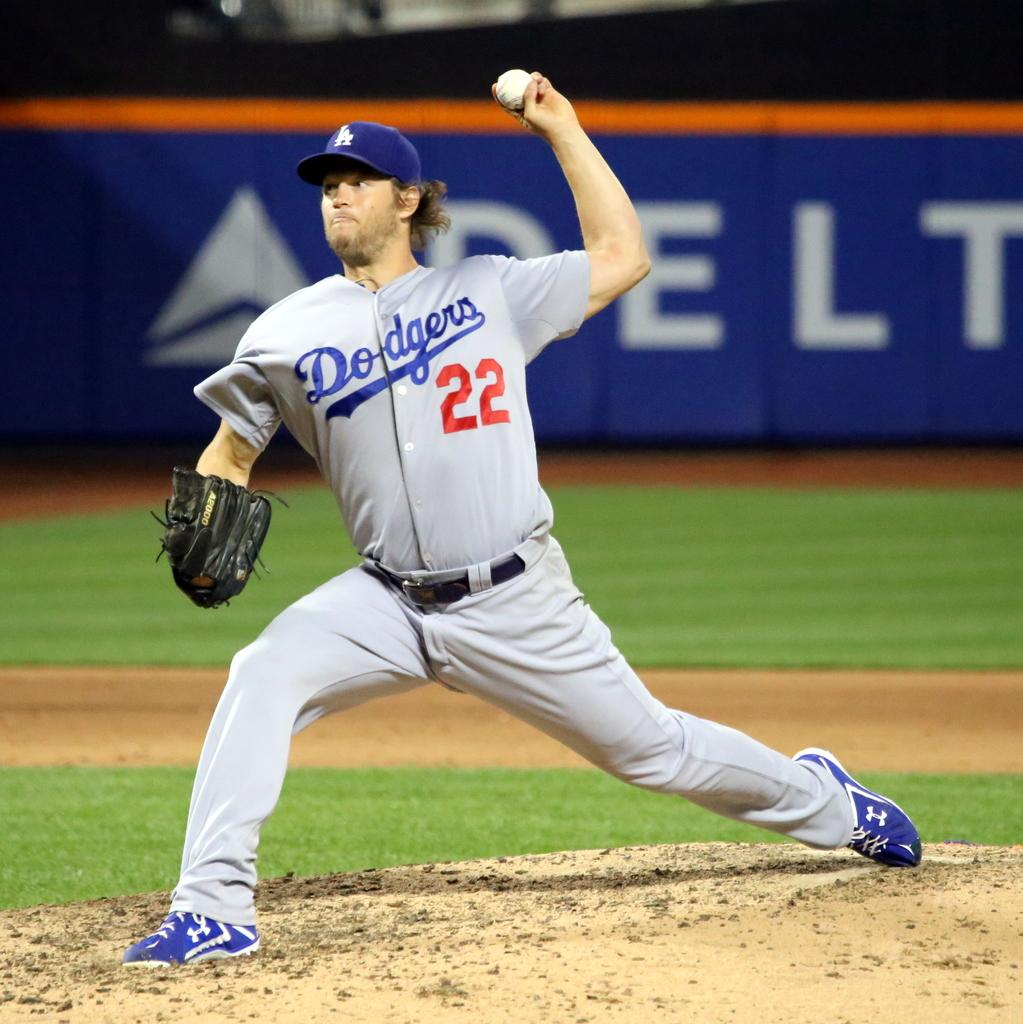Provide a one-sentence caption for the provided image. Player number 22 for the Dodgers gets ready to throw the baseball. 